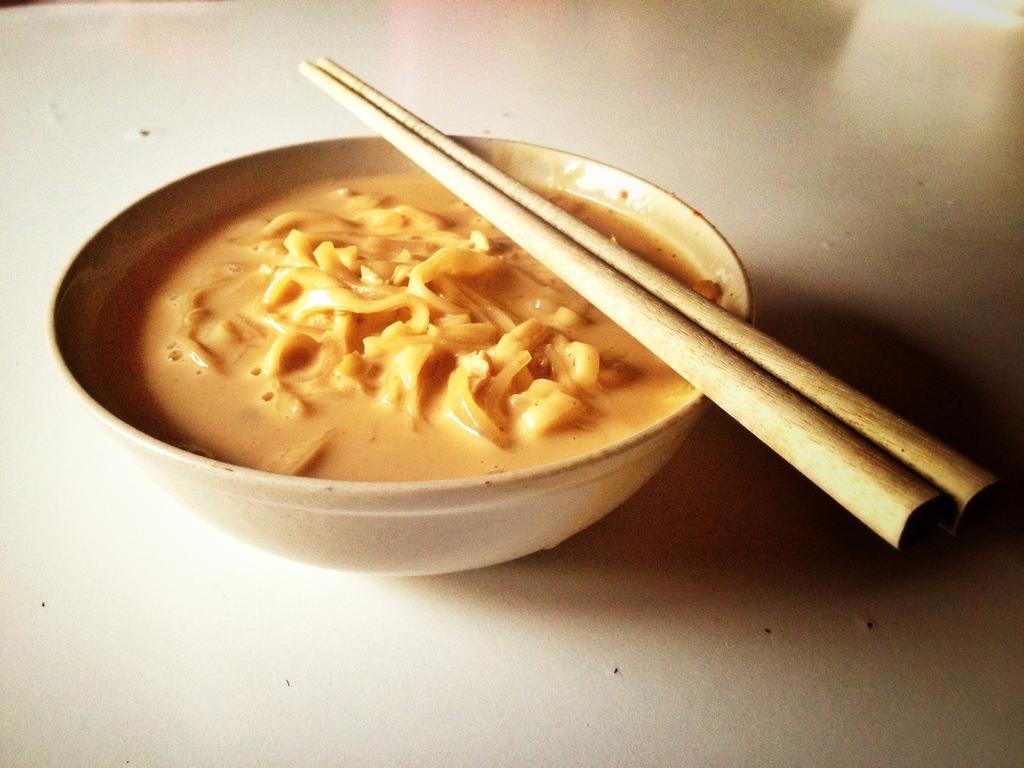Could you give a brief overview of what you see in this image? There is a bowl. The curry is in the bowl. There is a chopsticks on a bowl. 